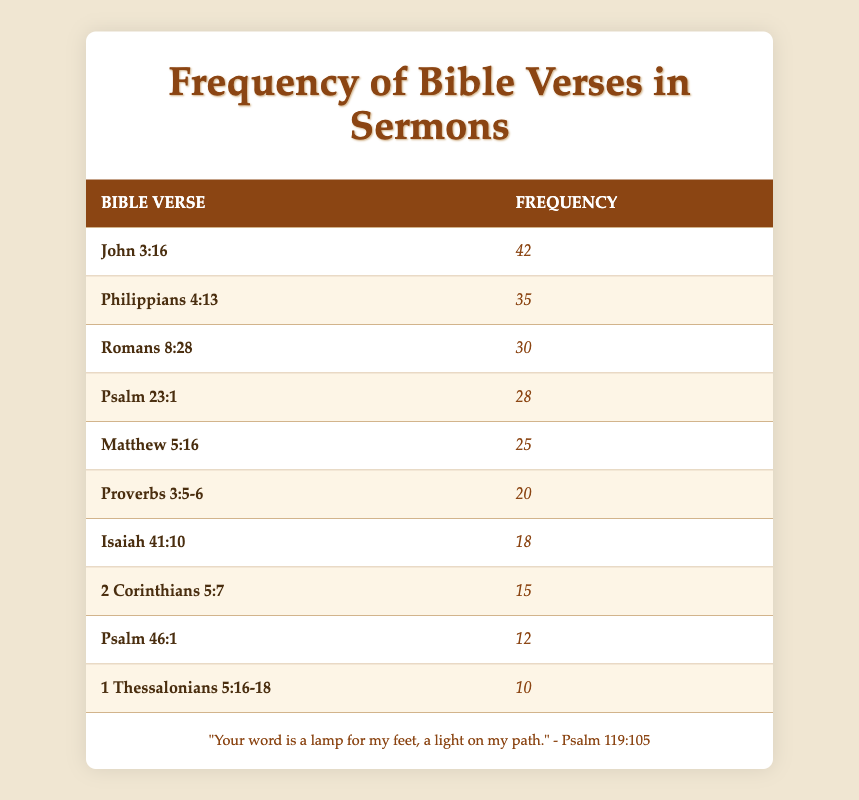What is the most frequently quoted Bible verse? The verse with the highest frequency listed in the table is "John 3:16," which has a frequency of 42.
Answer: John 3:16 How many times was "Philippians 4:13" quoted? The frequency for "Philippians 4:13" is directly shown in the table as 35.
Answer: 35 What is the average frequency of the top three quoted verses? The top three verses are "John 3:16" (42), "Philippians 4:13" (35), and "Romans 8:28" (30). Adding them gives 42 + 35 + 30 = 107. Dividing by 3 results in an average of 107/3 = 35.67.
Answer: 35.67 Is "Psalm 46:1" quoted more than "2 Corinthians 5:7"? The frequency of "Psalm 46:1" is 12, while the frequency of "2 Corinthians 5:7" is 15. Since 12 is less than 15, the statement is false.
Answer: No Which verse has a frequency closest to the median frequency of all verses? First, we order the frequencies: 10, 12, 15, 18, 20, 25, 28, 30, 35, 42. There are 10 values, so the median is the average of the 5th and 6th values: (20 + 25)/2 = 22.5. The frequency closest to this value is "Proverbs 3:5-6" with 20.
Answer: Proverbs 3:5-6 How many Bible verses were quoted more than 20 times? From the table, the verses with frequencies higher than 20 are "John 3:16", "Philippians 4:13", "Romans 8:28", "Psalm 23:1", "Matthew 5:16", and "Proverbs 3:5-6". Counting these, we find there are 6 verses.
Answer: 6 What is the frequency difference between "Isaiah 41:10" and "1 Thessalonians 5:16-18"? The frequency for "Isaiah 41:10" is 18, and for "1 Thessalonians 5:16-18", it is 10. The difference is 18 - 10 = 8.
Answer: 8 Which two verses have the lowest frequencies, and what are their frequencies? The lowest frequencies in the table are for "1 Thessalonians 5:16-18" (10) and "Psalm 46:1" (12). Thus, the two verses are listed accordingly along with their frequencies.
Answer: 1 Thessalonians 5:16-18: 10, Psalm 46:1: 12 How many times was "Romans 8:28" quoted compared to "Psalm 23:1"? "Romans 8:28" has a frequency of 30, while "Psalm 23:1" has a frequency of 28. The comparison shows that "Romans 8:28" was quoted 2 more times than "Psalm 23:1."
Answer: 2 times more 